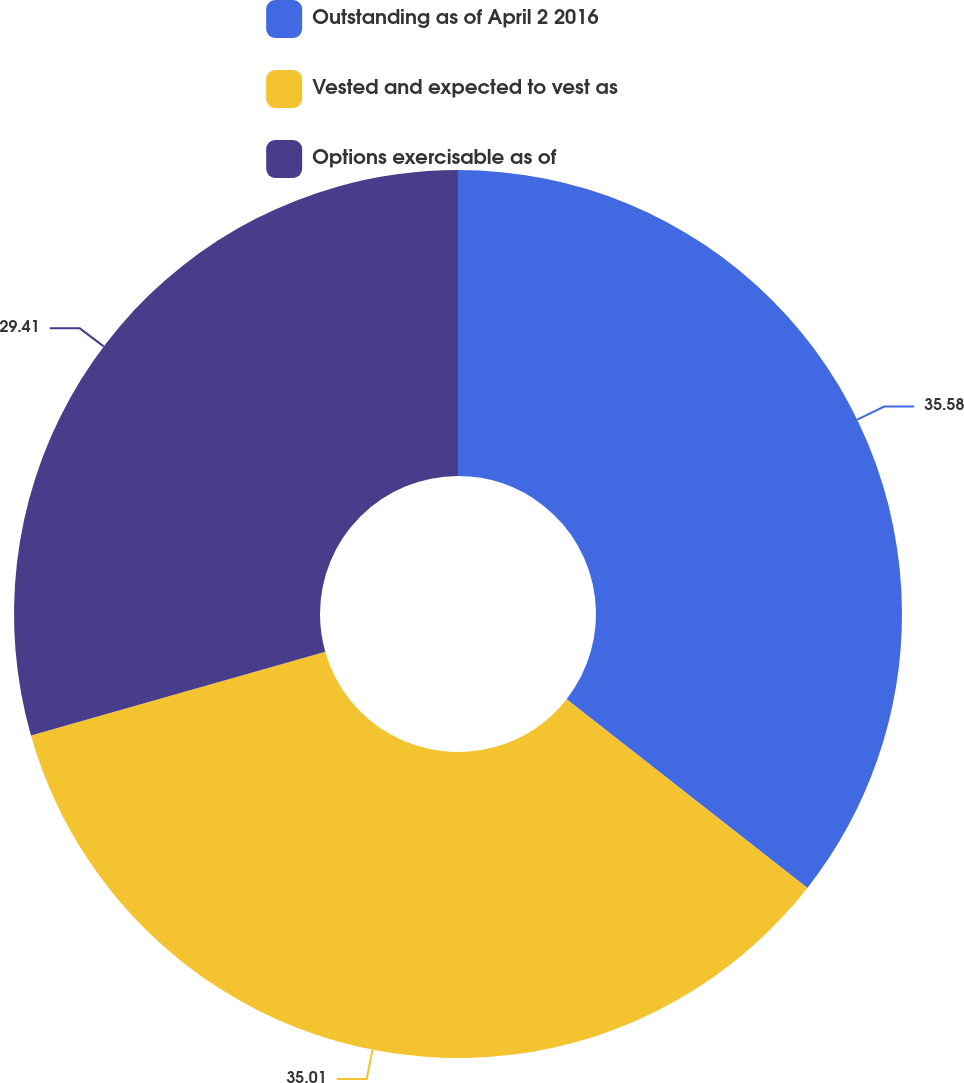Convert chart. <chart><loc_0><loc_0><loc_500><loc_500><pie_chart><fcel>Outstanding as of April 2 2016<fcel>Vested and expected to vest as<fcel>Options exercisable as of<nl><fcel>35.58%<fcel>35.01%<fcel>29.41%<nl></chart> 